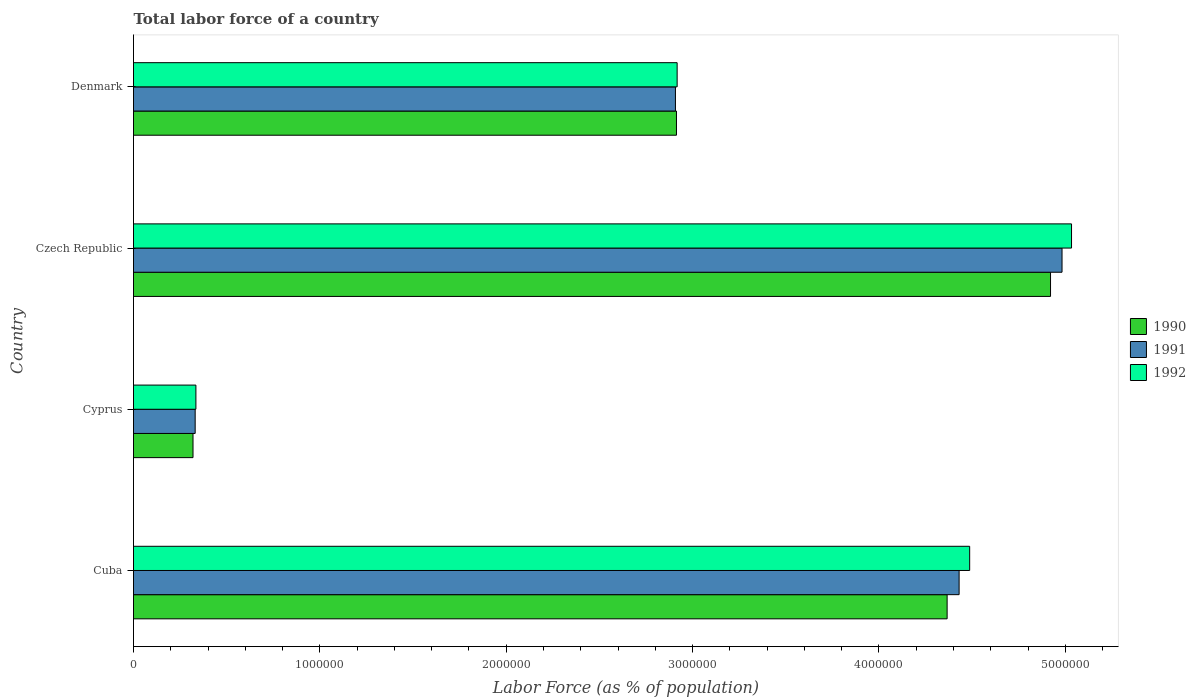How many different coloured bars are there?
Make the answer very short. 3. Are the number of bars on each tick of the Y-axis equal?
Provide a short and direct response. Yes. How many bars are there on the 3rd tick from the bottom?
Provide a succinct answer. 3. What is the label of the 3rd group of bars from the top?
Give a very brief answer. Cyprus. In how many cases, is the number of bars for a given country not equal to the number of legend labels?
Your answer should be very brief. 0. What is the percentage of labor force in 1992 in Denmark?
Offer a terse response. 2.92e+06. Across all countries, what is the maximum percentage of labor force in 1990?
Offer a terse response. 4.92e+06. Across all countries, what is the minimum percentage of labor force in 1991?
Make the answer very short. 3.31e+05. In which country was the percentage of labor force in 1992 maximum?
Your answer should be very brief. Czech Republic. In which country was the percentage of labor force in 1991 minimum?
Make the answer very short. Cyprus. What is the total percentage of labor force in 1992 in the graph?
Keep it short and to the point. 1.28e+07. What is the difference between the percentage of labor force in 1992 in Cyprus and that in Denmark?
Ensure brevity in your answer.  -2.58e+06. What is the difference between the percentage of labor force in 1990 in Denmark and the percentage of labor force in 1991 in Cyprus?
Make the answer very short. 2.58e+06. What is the average percentage of labor force in 1990 per country?
Give a very brief answer. 3.13e+06. What is the difference between the percentage of labor force in 1991 and percentage of labor force in 1992 in Czech Republic?
Your response must be concise. -5.09e+04. In how many countries, is the percentage of labor force in 1991 greater than 3600000 %?
Ensure brevity in your answer.  2. What is the ratio of the percentage of labor force in 1990 in Cuba to that in Czech Republic?
Provide a short and direct response. 0.89. Is the percentage of labor force in 1990 in Cyprus less than that in Czech Republic?
Your response must be concise. Yes. What is the difference between the highest and the second highest percentage of labor force in 1992?
Provide a short and direct response. 5.47e+05. What is the difference between the highest and the lowest percentage of labor force in 1991?
Ensure brevity in your answer.  4.65e+06. In how many countries, is the percentage of labor force in 1991 greater than the average percentage of labor force in 1991 taken over all countries?
Your answer should be very brief. 2. Is the sum of the percentage of labor force in 1991 in Cuba and Denmark greater than the maximum percentage of labor force in 1990 across all countries?
Offer a terse response. Yes. What does the 2nd bar from the top in Czech Republic represents?
Your answer should be very brief. 1991. What does the 1st bar from the bottom in Czech Republic represents?
Give a very brief answer. 1990. Is it the case that in every country, the sum of the percentage of labor force in 1990 and percentage of labor force in 1991 is greater than the percentage of labor force in 1992?
Make the answer very short. Yes. Are all the bars in the graph horizontal?
Your response must be concise. Yes. Are the values on the major ticks of X-axis written in scientific E-notation?
Keep it short and to the point. No. Where does the legend appear in the graph?
Your answer should be compact. Center right. How many legend labels are there?
Keep it short and to the point. 3. What is the title of the graph?
Give a very brief answer. Total labor force of a country. What is the label or title of the X-axis?
Your answer should be very brief. Labor Force (as % of population). What is the label or title of the Y-axis?
Ensure brevity in your answer.  Country. What is the Labor Force (as % of population) in 1990 in Cuba?
Make the answer very short. 4.37e+06. What is the Labor Force (as % of population) of 1991 in Cuba?
Your answer should be very brief. 4.43e+06. What is the Labor Force (as % of population) of 1992 in Cuba?
Your answer should be very brief. 4.49e+06. What is the Labor Force (as % of population) in 1990 in Cyprus?
Keep it short and to the point. 3.19e+05. What is the Labor Force (as % of population) in 1991 in Cyprus?
Ensure brevity in your answer.  3.31e+05. What is the Labor Force (as % of population) in 1992 in Cyprus?
Provide a succinct answer. 3.35e+05. What is the Labor Force (as % of population) in 1990 in Czech Republic?
Offer a very short reply. 4.92e+06. What is the Labor Force (as % of population) in 1991 in Czech Republic?
Offer a terse response. 4.98e+06. What is the Labor Force (as % of population) in 1992 in Czech Republic?
Provide a succinct answer. 5.03e+06. What is the Labor Force (as % of population) in 1990 in Denmark?
Offer a terse response. 2.91e+06. What is the Labor Force (as % of population) of 1991 in Denmark?
Provide a succinct answer. 2.91e+06. What is the Labor Force (as % of population) of 1992 in Denmark?
Your response must be concise. 2.92e+06. Across all countries, what is the maximum Labor Force (as % of population) of 1990?
Keep it short and to the point. 4.92e+06. Across all countries, what is the maximum Labor Force (as % of population) in 1991?
Give a very brief answer. 4.98e+06. Across all countries, what is the maximum Labor Force (as % of population) of 1992?
Provide a short and direct response. 5.03e+06. Across all countries, what is the minimum Labor Force (as % of population) in 1990?
Your answer should be very brief. 3.19e+05. Across all countries, what is the minimum Labor Force (as % of population) of 1991?
Your answer should be compact. 3.31e+05. Across all countries, what is the minimum Labor Force (as % of population) in 1992?
Keep it short and to the point. 3.35e+05. What is the total Labor Force (as % of population) in 1990 in the graph?
Offer a terse response. 1.25e+07. What is the total Labor Force (as % of population) in 1991 in the graph?
Give a very brief answer. 1.27e+07. What is the total Labor Force (as % of population) of 1992 in the graph?
Keep it short and to the point. 1.28e+07. What is the difference between the Labor Force (as % of population) in 1990 in Cuba and that in Cyprus?
Your answer should be very brief. 4.05e+06. What is the difference between the Labor Force (as % of population) in 1991 in Cuba and that in Cyprus?
Make the answer very short. 4.10e+06. What is the difference between the Labor Force (as % of population) in 1992 in Cuba and that in Cyprus?
Provide a succinct answer. 4.15e+06. What is the difference between the Labor Force (as % of population) in 1990 in Cuba and that in Czech Republic?
Your answer should be very brief. -5.55e+05. What is the difference between the Labor Force (as % of population) of 1991 in Cuba and that in Czech Republic?
Provide a short and direct response. -5.52e+05. What is the difference between the Labor Force (as % of population) of 1992 in Cuba and that in Czech Republic?
Offer a very short reply. -5.47e+05. What is the difference between the Labor Force (as % of population) of 1990 in Cuba and that in Denmark?
Provide a short and direct response. 1.45e+06. What is the difference between the Labor Force (as % of population) of 1991 in Cuba and that in Denmark?
Ensure brevity in your answer.  1.52e+06. What is the difference between the Labor Force (as % of population) in 1992 in Cuba and that in Denmark?
Provide a short and direct response. 1.57e+06. What is the difference between the Labor Force (as % of population) in 1990 in Cyprus and that in Czech Republic?
Your response must be concise. -4.60e+06. What is the difference between the Labor Force (as % of population) in 1991 in Cyprus and that in Czech Republic?
Your answer should be very brief. -4.65e+06. What is the difference between the Labor Force (as % of population) in 1992 in Cyprus and that in Czech Republic?
Your answer should be very brief. -4.70e+06. What is the difference between the Labor Force (as % of population) of 1990 in Cyprus and that in Denmark?
Give a very brief answer. -2.59e+06. What is the difference between the Labor Force (as % of population) in 1991 in Cyprus and that in Denmark?
Offer a terse response. -2.58e+06. What is the difference between the Labor Force (as % of population) of 1992 in Cyprus and that in Denmark?
Provide a succinct answer. -2.58e+06. What is the difference between the Labor Force (as % of population) in 1990 in Czech Republic and that in Denmark?
Offer a very short reply. 2.01e+06. What is the difference between the Labor Force (as % of population) in 1991 in Czech Republic and that in Denmark?
Your answer should be compact. 2.07e+06. What is the difference between the Labor Force (as % of population) in 1992 in Czech Republic and that in Denmark?
Offer a terse response. 2.12e+06. What is the difference between the Labor Force (as % of population) of 1990 in Cuba and the Labor Force (as % of population) of 1991 in Cyprus?
Your answer should be very brief. 4.04e+06. What is the difference between the Labor Force (as % of population) in 1990 in Cuba and the Labor Force (as % of population) in 1992 in Cyprus?
Offer a terse response. 4.03e+06. What is the difference between the Labor Force (as % of population) of 1991 in Cuba and the Labor Force (as % of population) of 1992 in Cyprus?
Offer a terse response. 4.10e+06. What is the difference between the Labor Force (as % of population) in 1990 in Cuba and the Labor Force (as % of population) in 1991 in Czech Republic?
Ensure brevity in your answer.  -6.17e+05. What is the difference between the Labor Force (as % of population) of 1990 in Cuba and the Labor Force (as % of population) of 1992 in Czech Republic?
Make the answer very short. -6.68e+05. What is the difference between the Labor Force (as % of population) of 1991 in Cuba and the Labor Force (as % of population) of 1992 in Czech Republic?
Provide a succinct answer. -6.03e+05. What is the difference between the Labor Force (as % of population) of 1990 in Cuba and the Labor Force (as % of population) of 1991 in Denmark?
Your response must be concise. 1.46e+06. What is the difference between the Labor Force (as % of population) in 1990 in Cuba and the Labor Force (as % of population) in 1992 in Denmark?
Provide a succinct answer. 1.45e+06. What is the difference between the Labor Force (as % of population) of 1991 in Cuba and the Labor Force (as % of population) of 1992 in Denmark?
Ensure brevity in your answer.  1.51e+06. What is the difference between the Labor Force (as % of population) of 1990 in Cyprus and the Labor Force (as % of population) of 1991 in Czech Republic?
Ensure brevity in your answer.  -4.66e+06. What is the difference between the Labor Force (as % of population) of 1990 in Cyprus and the Labor Force (as % of population) of 1992 in Czech Republic?
Make the answer very short. -4.71e+06. What is the difference between the Labor Force (as % of population) of 1991 in Cyprus and the Labor Force (as % of population) of 1992 in Czech Republic?
Your answer should be compact. -4.70e+06. What is the difference between the Labor Force (as % of population) of 1990 in Cyprus and the Labor Force (as % of population) of 1991 in Denmark?
Provide a succinct answer. -2.59e+06. What is the difference between the Labor Force (as % of population) in 1990 in Cyprus and the Labor Force (as % of population) in 1992 in Denmark?
Your response must be concise. -2.60e+06. What is the difference between the Labor Force (as % of population) of 1991 in Cyprus and the Labor Force (as % of population) of 1992 in Denmark?
Offer a terse response. -2.59e+06. What is the difference between the Labor Force (as % of population) of 1990 in Czech Republic and the Labor Force (as % of population) of 1991 in Denmark?
Keep it short and to the point. 2.01e+06. What is the difference between the Labor Force (as % of population) of 1990 in Czech Republic and the Labor Force (as % of population) of 1992 in Denmark?
Your answer should be very brief. 2.00e+06. What is the difference between the Labor Force (as % of population) of 1991 in Czech Republic and the Labor Force (as % of population) of 1992 in Denmark?
Ensure brevity in your answer.  2.07e+06. What is the average Labor Force (as % of population) of 1990 per country?
Provide a short and direct response. 3.13e+06. What is the average Labor Force (as % of population) in 1991 per country?
Offer a terse response. 3.16e+06. What is the average Labor Force (as % of population) of 1992 per country?
Ensure brevity in your answer.  3.19e+06. What is the difference between the Labor Force (as % of population) in 1990 and Labor Force (as % of population) in 1991 in Cuba?
Give a very brief answer. -6.43e+04. What is the difference between the Labor Force (as % of population) in 1990 and Labor Force (as % of population) in 1992 in Cuba?
Your response must be concise. -1.21e+05. What is the difference between the Labor Force (as % of population) of 1991 and Labor Force (as % of population) of 1992 in Cuba?
Your answer should be compact. -5.67e+04. What is the difference between the Labor Force (as % of population) in 1990 and Labor Force (as % of population) in 1991 in Cyprus?
Ensure brevity in your answer.  -1.16e+04. What is the difference between the Labor Force (as % of population) of 1990 and Labor Force (as % of population) of 1992 in Cyprus?
Your response must be concise. -1.55e+04. What is the difference between the Labor Force (as % of population) of 1991 and Labor Force (as % of population) of 1992 in Cyprus?
Give a very brief answer. -3948. What is the difference between the Labor Force (as % of population) of 1990 and Labor Force (as % of population) of 1991 in Czech Republic?
Offer a terse response. -6.18e+04. What is the difference between the Labor Force (as % of population) in 1990 and Labor Force (as % of population) in 1992 in Czech Republic?
Offer a terse response. -1.13e+05. What is the difference between the Labor Force (as % of population) in 1991 and Labor Force (as % of population) in 1992 in Czech Republic?
Ensure brevity in your answer.  -5.09e+04. What is the difference between the Labor Force (as % of population) of 1990 and Labor Force (as % of population) of 1991 in Denmark?
Provide a short and direct response. 5525. What is the difference between the Labor Force (as % of population) of 1990 and Labor Force (as % of population) of 1992 in Denmark?
Provide a short and direct response. -3632. What is the difference between the Labor Force (as % of population) in 1991 and Labor Force (as % of population) in 1992 in Denmark?
Offer a terse response. -9157. What is the ratio of the Labor Force (as % of population) in 1990 in Cuba to that in Cyprus?
Keep it short and to the point. 13.67. What is the ratio of the Labor Force (as % of population) of 1991 in Cuba to that in Cyprus?
Your answer should be very brief. 13.39. What is the ratio of the Labor Force (as % of population) in 1992 in Cuba to that in Cyprus?
Give a very brief answer. 13.4. What is the ratio of the Labor Force (as % of population) in 1990 in Cuba to that in Czech Republic?
Ensure brevity in your answer.  0.89. What is the ratio of the Labor Force (as % of population) of 1991 in Cuba to that in Czech Republic?
Your response must be concise. 0.89. What is the ratio of the Labor Force (as % of population) in 1992 in Cuba to that in Czech Republic?
Give a very brief answer. 0.89. What is the ratio of the Labor Force (as % of population) in 1990 in Cuba to that in Denmark?
Keep it short and to the point. 1.5. What is the ratio of the Labor Force (as % of population) in 1991 in Cuba to that in Denmark?
Your answer should be very brief. 1.52. What is the ratio of the Labor Force (as % of population) of 1992 in Cuba to that in Denmark?
Your answer should be compact. 1.54. What is the ratio of the Labor Force (as % of population) in 1990 in Cyprus to that in Czech Republic?
Your answer should be compact. 0.06. What is the ratio of the Labor Force (as % of population) of 1991 in Cyprus to that in Czech Republic?
Offer a very short reply. 0.07. What is the ratio of the Labor Force (as % of population) of 1992 in Cyprus to that in Czech Republic?
Your answer should be very brief. 0.07. What is the ratio of the Labor Force (as % of population) in 1990 in Cyprus to that in Denmark?
Offer a terse response. 0.11. What is the ratio of the Labor Force (as % of population) in 1991 in Cyprus to that in Denmark?
Ensure brevity in your answer.  0.11. What is the ratio of the Labor Force (as % of population) of 1992 in Cyprus to that in Denmark?
Your answer should be very brief. 0.11. What is the ratio of the Labor Force (as % of population) in 1990 in Czech Republic to that in Denmark?
Make the answer very short. 1.69. What is the ratio of the Labor Force (as % of population) in 1991 in Czech Republic to that in Denmark?
Ensure brevity in your answer.  1.71. What is the ratio of the Labor Force (as % of population) in 1992 in Czech Republic to that in Denmark?
Give a very brief answer. 1.73. What is the difference between the highest and the second highest Labor Force (as % of population) in 1990?
Make the answer very short. 5.55e+05. What is the difference between the highest and the second highest Labor Force (as % of population) in 1991?
Your answer should be compact. 5.52e+05. What is the difference between the highest and the second highest Labor Force (as % of population) in 1992?
Your answer should be very brief. 5.47e+05. What is the difference between the highest and the lowest Labor Force (as % of population) of 1990?
Your response must be concise. 4.60e+06. What is the difference between the highest and the lowest Labor Force (as % of population) of 1991?
Offer a very short reply. 4.65e+06. What is the difference between the highest and the lowest Labor Force (as % of population) in 1992?
Make the answer very short. 4.70e+06. 